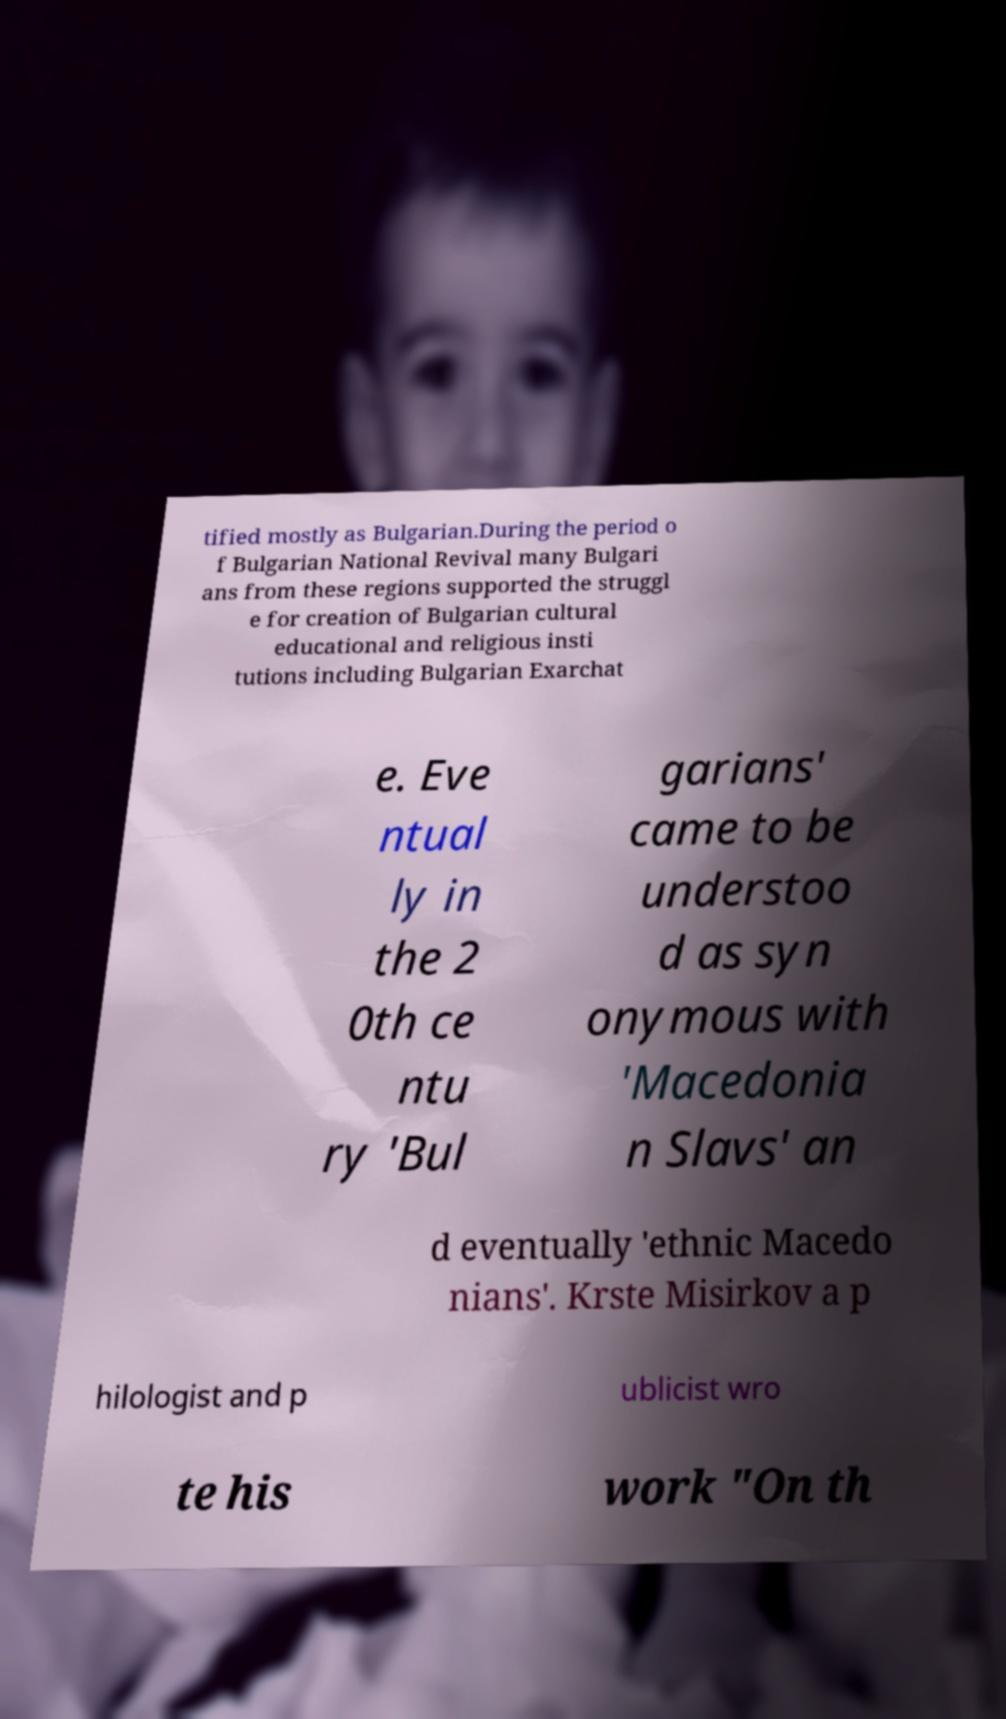What messages or text are displayed in this image? I need them in a readable, typed format. tified mostly as Bulgarian.During the period o f Bulgarian National Revival many Bulgari ans from these regions supported the struggl e for creation of Bulgarian cultural educational and religious insti tutions including Bulgarian Exarchat e. Eve ntual ly in the 2 0th ce ntu ry 'Bul garians' came to be understoo d as syn onymous with 'Macedonia n Slavs' an d eventually 'ethnic Macedo nians'. Krste Misirkov a p hilologist and p ublicist wro te his work "On th 